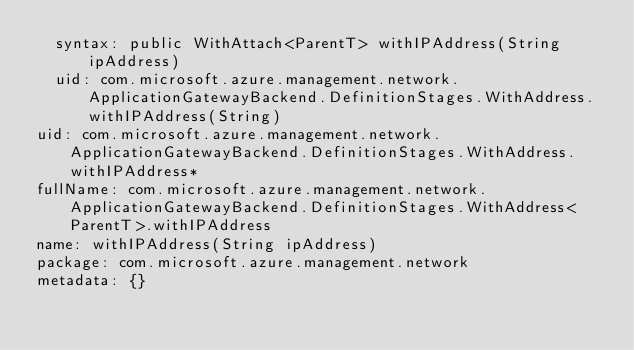Convert code to text. <code><loc_0><loc_0><loc_500><loc_500><_YAML_>  syntax: public WithAttach<ParentT> withIPAddress(String ipAddress)
  uid: com.microsoft.azure.management.network.ApplicationGatewayBackend.DefinitionStages.WithAddress.withIPAddress(String)
uid: com.microsoft.azure.management.network.ApplicationGatewayBackend.DefinitionStages.WithAddress.withIPAddress*
fullName: com.microsoft.azure.management.network.ApplicationGatewayBackend.DefinitionStages.WithAddress<ParentT>.withIPAddress
name: withIPAddress(String ipAddress)
package: com.microsoft.azure.management.network
metadata: {}
</code> 